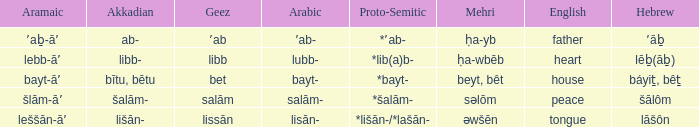If the proto-semitic is *bayt-, what are the geez? Bet. 